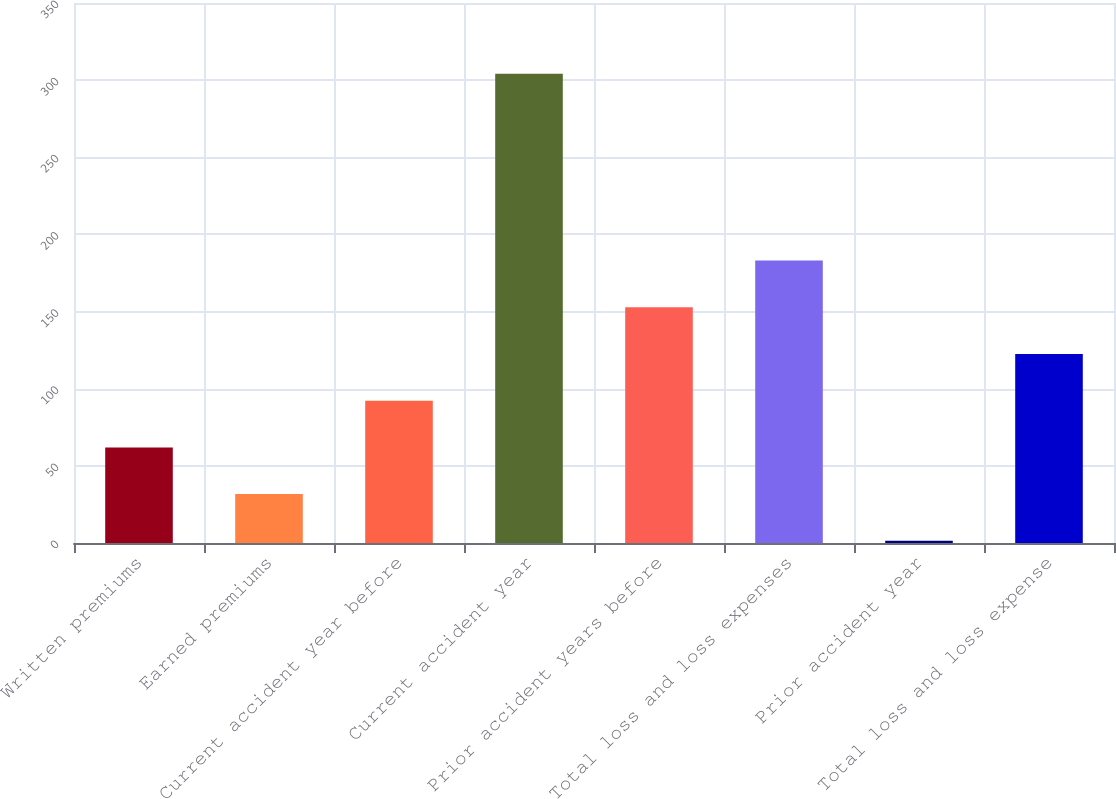Convert chart. <chart><loc_0><loc_0><loc_500><loc_500><bar_chart><fcel>Written premiums<fcel>Earned premiums<fcel>Current accident year before<fcel>Current accident year<fcel>Prior accident years before<fcel>Total loss and loss expenses<fcel>Prior accident year<fcel>Total loss and loss expense<nl><fcel>61.96<fcel>31.68<fcel>92.24<fcel>304.2<fcel>152.8<fcel>183.08<fcel>1.4<fcel>122.52<nl></chart> 